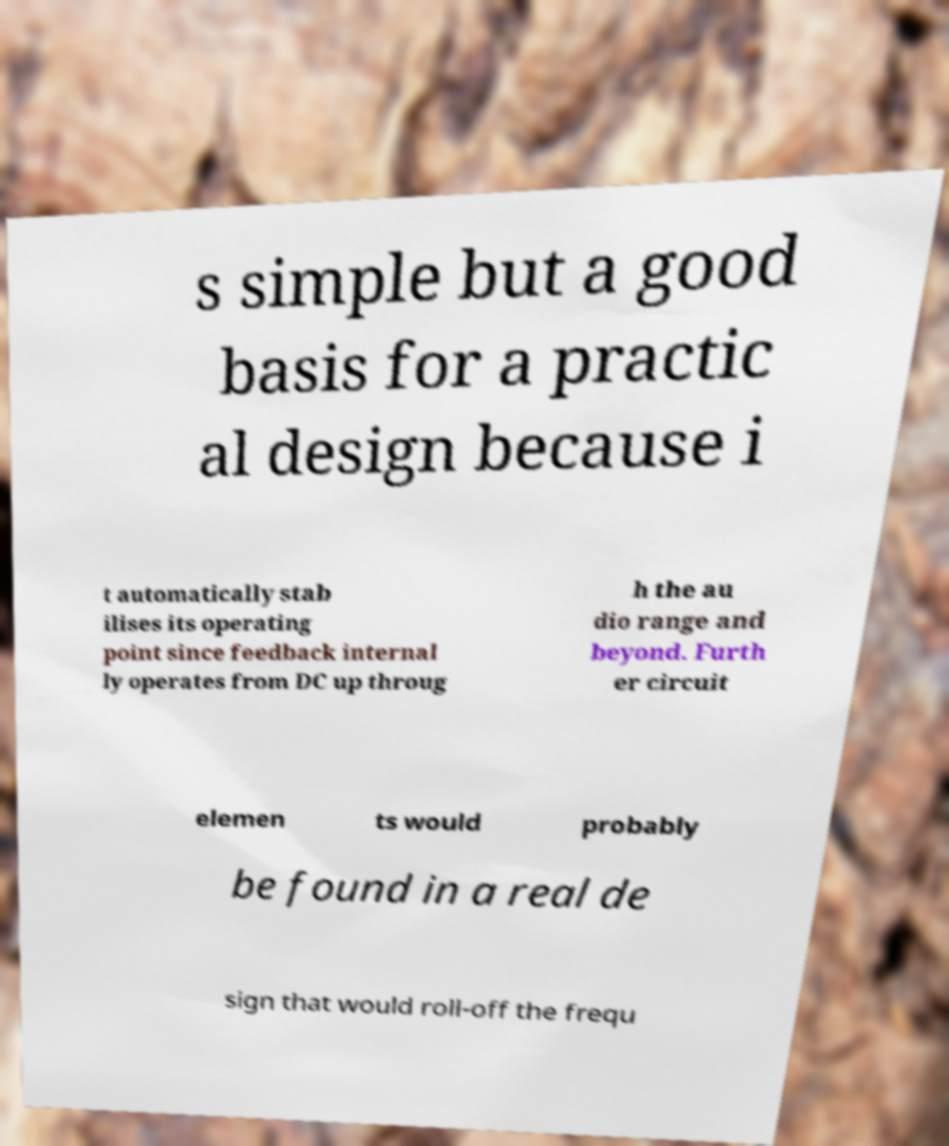For documentation purposes, I need the text within this image transcribed. Could you provide that? s simple but a good basis for a practic al design because i t automatically stab ilises its operating point since feedback internal ly operates from DC up throug h the au dio range and beyond. Furth er circuit elemen ts would probably be found in a real de sign that would roll-off the frequ 